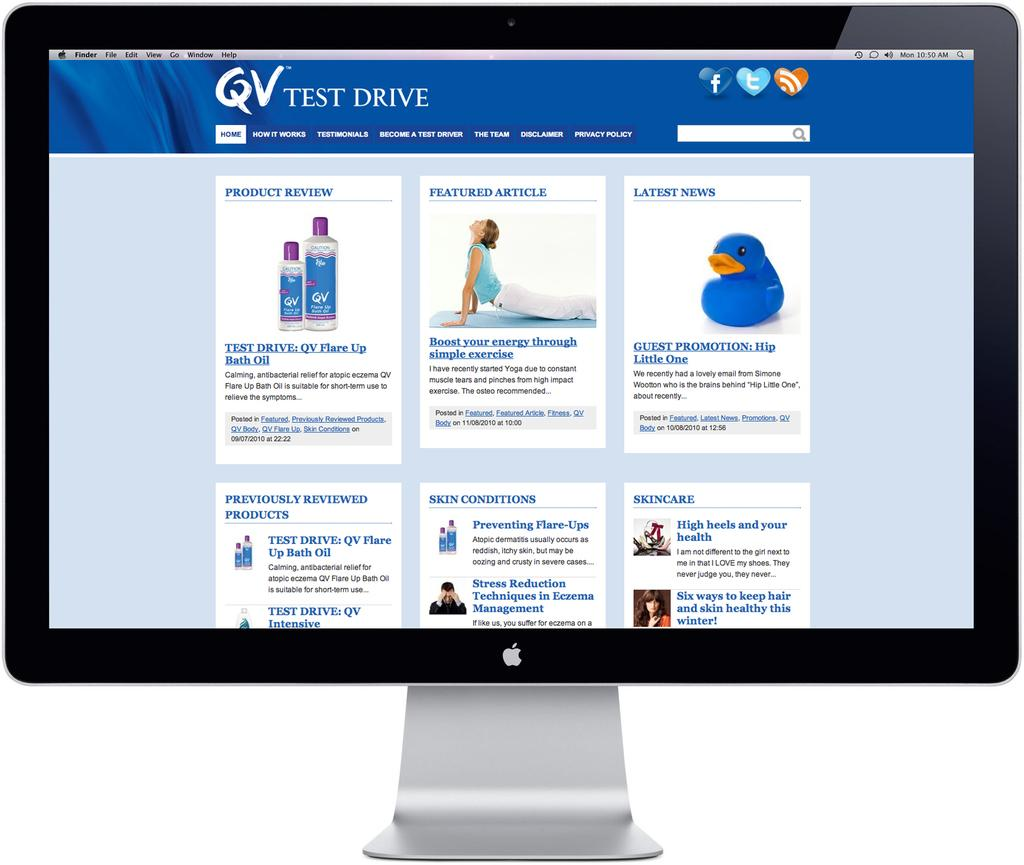Provide a one-sentence caption for the provided image. The blue and white website is by Test Drive. 